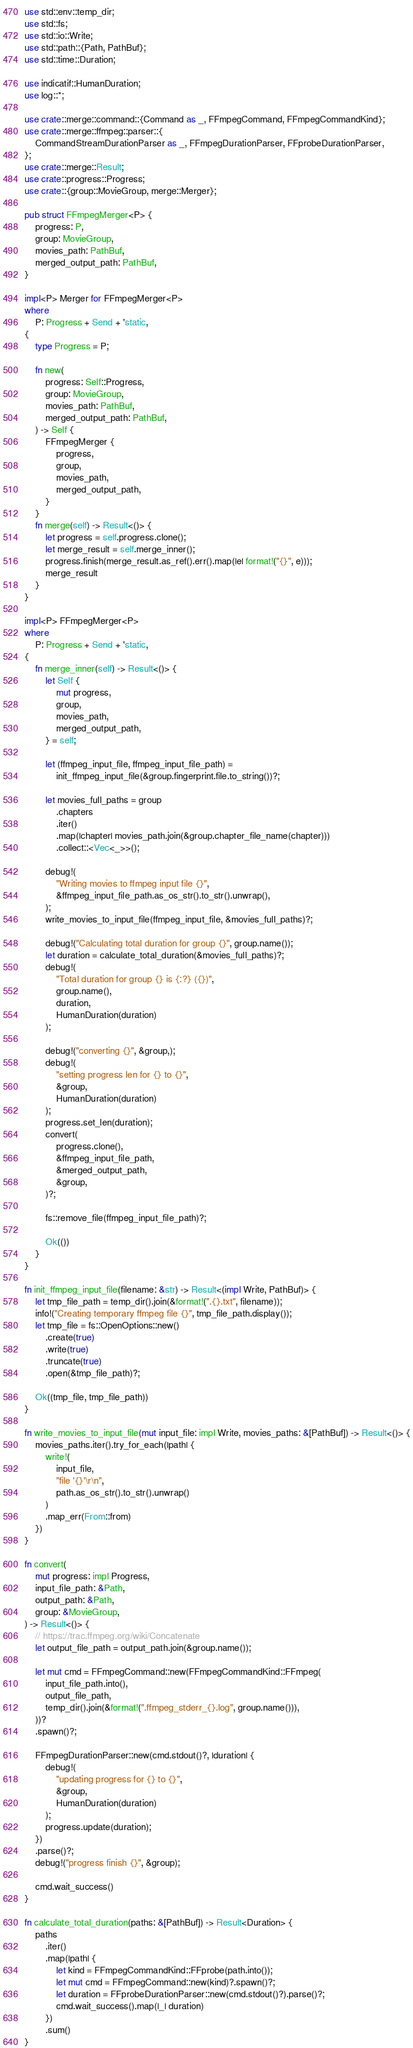Convert code to text. <code><loc_0><loc_0><loc_500><loc_500><_Rust_>use std::env::temp_dir;
use std::fs;
use std::io::Write;
use std::path::{Path, PathBuf};
use std::time::Duration;

use indicatif::HumanDuration;
use log::*;

use crate::merge::command::{Command as _, FFmpegCommand, FFmpegCommandKind};
use crate::merge::ffmpeg::parser::{
    CommandStreamDurationParser as _, FFmpegDurationParser, FFprobeDurationParser,
};
use crate::merge::Result;
use crate::progress::Progress;
use crate::{group::MovieGroup, merge::Merger};

pub struct FFmpegMerger<P> {
    progress: P,
    group: MovieGroup,
    movies_path: PathBuf,
    merged_output_path: PathBuf,
}

impl<P> Merger for FFmpegMerger<P>
where
    P: Progress + Send + 'static,
{
    type Progress = P;

    fn new(
        progress: Self::Progress,
        group: MovieGroup,
        movies_path: PathBuf,
        merged_output_path: PathBuf,
    ) -> Self {
        FFmpegMerger {
            progress,
            group,
            movies_path,
            merged_output_path,
        }
    }
    fn merge(self) -> Result<()> {
        let progress = self.progress.clone();
        let merge_result = self.merge_inner();
        progress.finish(merge_result.as_ref().err().map(|e| format!("{}", e)));
        merge_result
    }
}

impl<P> FFmpegMerger<P>
where
    P: Progress + Send + 'static,
{
    fn merge_inner(self) -> Result<()> {
        let Self {
            mut progress,
            group,
            movies_path,
            merged_output_path,
        } = self;

        let (ffmpeg_input_file, ffmpeg_input_file_path) =
            init_ffmpeg_input_file(&group.fingerprint.file.to_string())?;

        let movies_full_paths = group
            .chapters
            .iter()
            .map(|chapter| movies_path.join(&group.chapter_file_name(chapter)))
            .collect::<Vec<_>>();

        debug!(
            "Writing movies to ffmpeg input file {}",
            &ffmpeg_input_file_path.as_os_str().to_str().unwrap(),
        );
        write_movies_to_input_file(ffmpeg_input_file, &movies_full_paths)?;

        debug!("Calculating total duration for group {}", group.name());
        let duration = calculate_total_duration(&movies_full_paths)?;
        debug!(
            "Total duration for group {} is {:?} ({})",
            group.name(),
            duration,
            HumanDuration(duration)
        );

        debug!("converting {}", &group,);
        debug!(
            "setting progress len for {} to {}",
            &group,
            HumanDuration(duration)
        );
        progress.set_len(duration);
        convert(
            progress.clone(),
            &ffmpeg_input_file_path,
            &merged_output_path,
            &group,
        )?;

        fs::remove_file(ffmpeg_input_file_path)?;

        Ok(())
    }
}

fn init_ffmpeg_input_file(filename: &str) -> Result<(impl Write, PathBuf)> {
    let tmp_file_path = temp_dir().join(&format!(".{}.txt", filename));
    info!("Creating temporary ffmpeg file {}", tmp_file_path.display());
    let tmp_file = fs::OpenOptions::new()
        .create(true)
        .write(true)
        .truncate(true)
        .open(&tmp_file_path)?;

    Ok((tmp_file, tmp_file_path))
}

fn write_movies_to_input_file(mut input_file: impl Write, movies_paths: &[PathBuf]) -> Result<()> {
    movies_paths.iter().try_for_each(|path| {
        write!(
            input_file,
            "file '{}'\r\n",
            path.as_os_str().to_str().unwrap()
        )
        .map_err(From::from)
    })
}

fn convert(
    mut progress: impl Progress,
    input_file_path: &Path,
    output_path: &Path,
    group: &MovieGroup,
) -> Result<()> {
    // https://trac.ffmpeg.org/wiki/Concatenate
    let output_file_path = output_path.join(&group.name());

    let mut cmd = FFmpegCommand::new(FFmpegCommandKind::FFmpeg(
        input_file_path.into(),
        output_file_path,
        temp_dir().join(&format!(".ffmpeg_stderr_{}.log", group.name())),
    ))?
    .spawn()?;

    FFmpegDurationParser::new(cmd.stdout()?, |duration| {
        debug!(
            "updating progress for {} to {}",
            &group,
            HumanDuration(duration)
        );
        progress.update(duration);
    })
    .parse()?;
    debug!("progress finish {}", &group);

    cmd.wait_success()
}

fn calculate_total_duration(paths: &[PathBuf]) -> Result<Duration> {
    paths
        .iter()
        .map(|path| {
            let kind = FFmpegCommandKind::FFprobe(path.into());
            let mut cmd = FFmpegCommand::new(kind)?.spawn()?;
            let duration = FFprobeDurationParser::new(cmd.stdout()?).parse()?;
            cmd.wait_success().map(|_| duration)
        })
        .sum()
}
</code> 